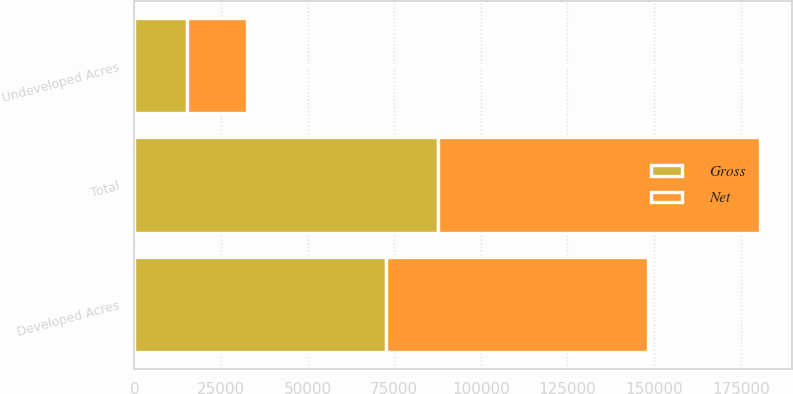Convert chart. <chart><loc_0><loc_0><loc_500><loc_500><stacked_bar_chart><ecel><fcel>Developed Acres<fcel>Undeveloped Acres<fcel>Total<nl><fcel>Net<fcel>75752<fcel>17282<fcel>93034<nl><fcel>Gross<fcel>72561<fcel>15093<fcel>87654<nl></chart> 